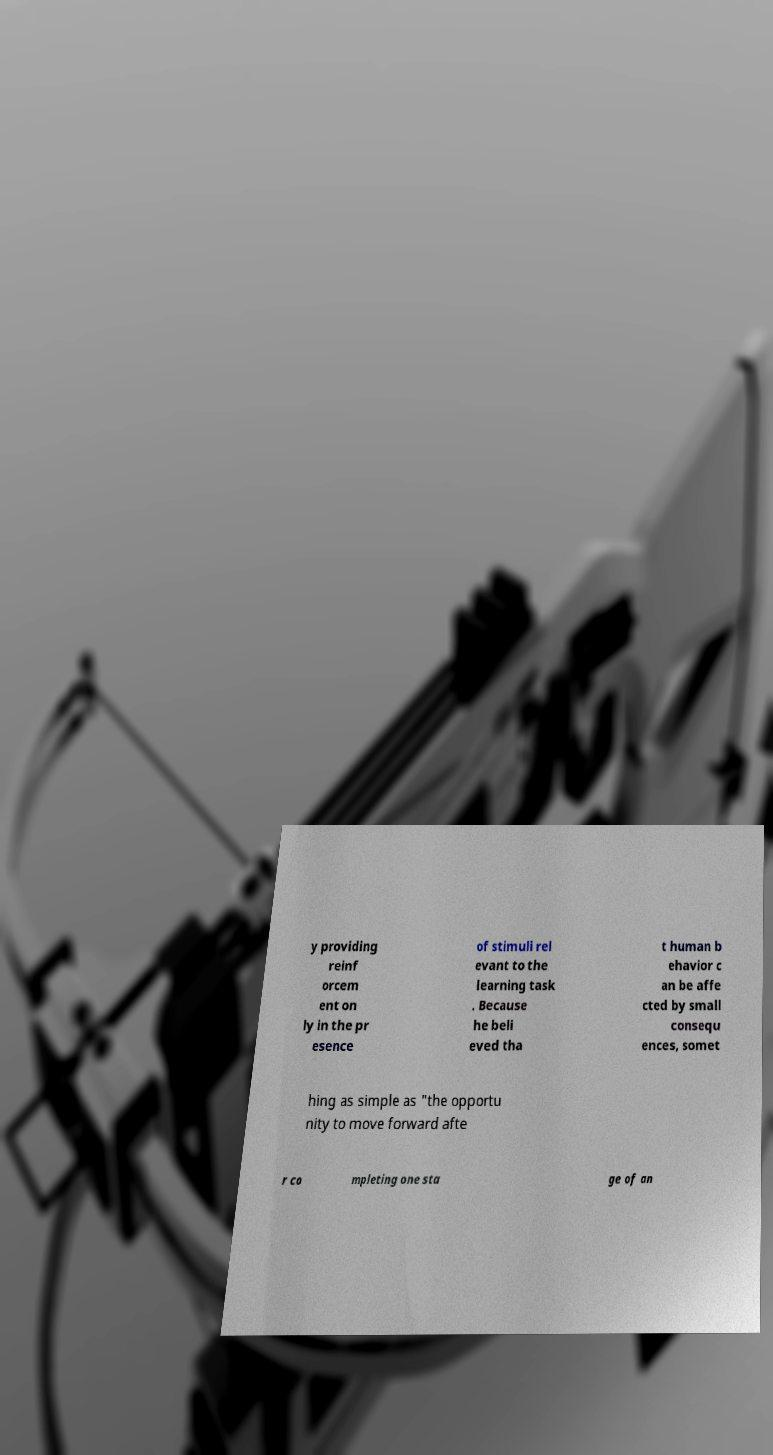There's text embedded in this image that I need extracted. Can you transcribe it verbatim? y providing reinf orcem ent on ly in the pr esence of stimuli rel evant to the learning task . Because he beli eved tha t human b ehavior c an be affe cted by small consequ ences, somet hing as simple as "the opportu nity to move forward afte r co mpleting one sta ge of an 